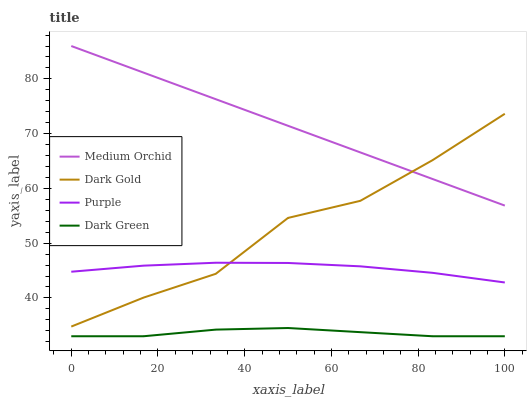Does Medium Orchid have the minimum area under the curve?
Answer yes or no. No. Does Dark Green have the maximum area under the curve?
Answer yes or no. No. Is Dark Green the smoothest?
Answer yes or no. No. Is Dark Green the roughest?
Answer yes or no. No. Does Medium Orchid have the lowest value?
Answer yes or no. No. Does Dark Green have the highest value?
Answer yes or no. No. Is Purple less than Medium Orchid?
Answer yes or no. Yes. Is Dark Gold greater than Dark Green?
Answer yes or no. Yes. Does Purple intersect Medium Orchid?
Answer yes or no. No. 